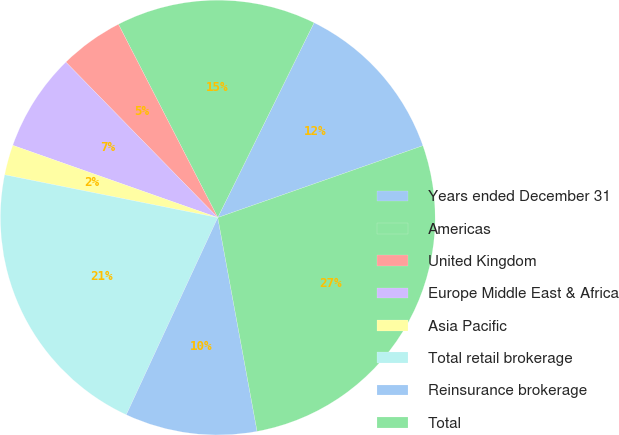<chart> <loc_0><loc_0><loc_500><loc_500><pie_chart><fcel>Years ended December 31<fcel>Americas<fcel>United Kingdom<fcel>Europe Middle East & Africa<fcel>Asia Pacific<fcel>Total retail brokerage<fcel>Reinsurance brokerage<fcel>Total<nl><fcel>12.33%<fcel>14.86%<fcel>4.76%<fcel>7.29%<fcel>2.24%<fcel>21.24%<fcel>9.81%<fcel>27.47%<nl></chart> 